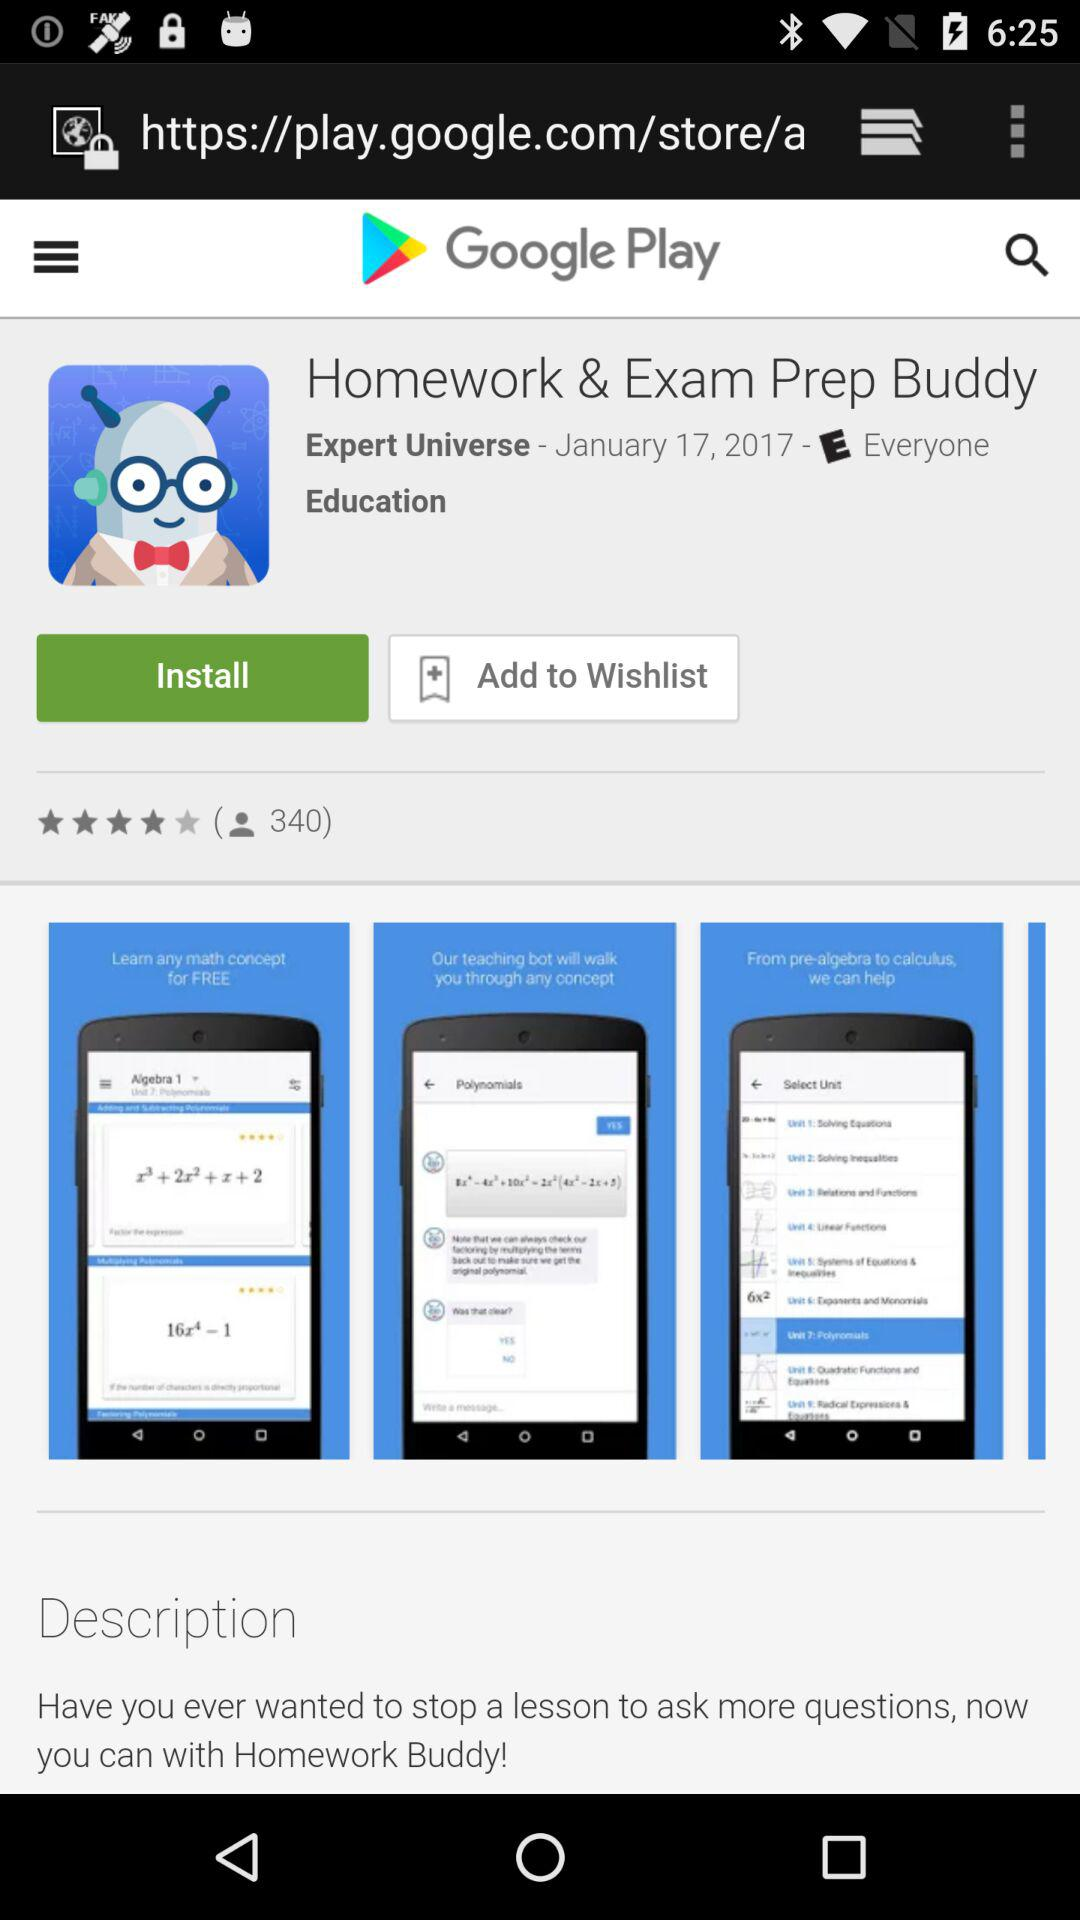How many people have rated the application "Homework and Exam Prep Buddy"? There are 340 people who have rated the application. 